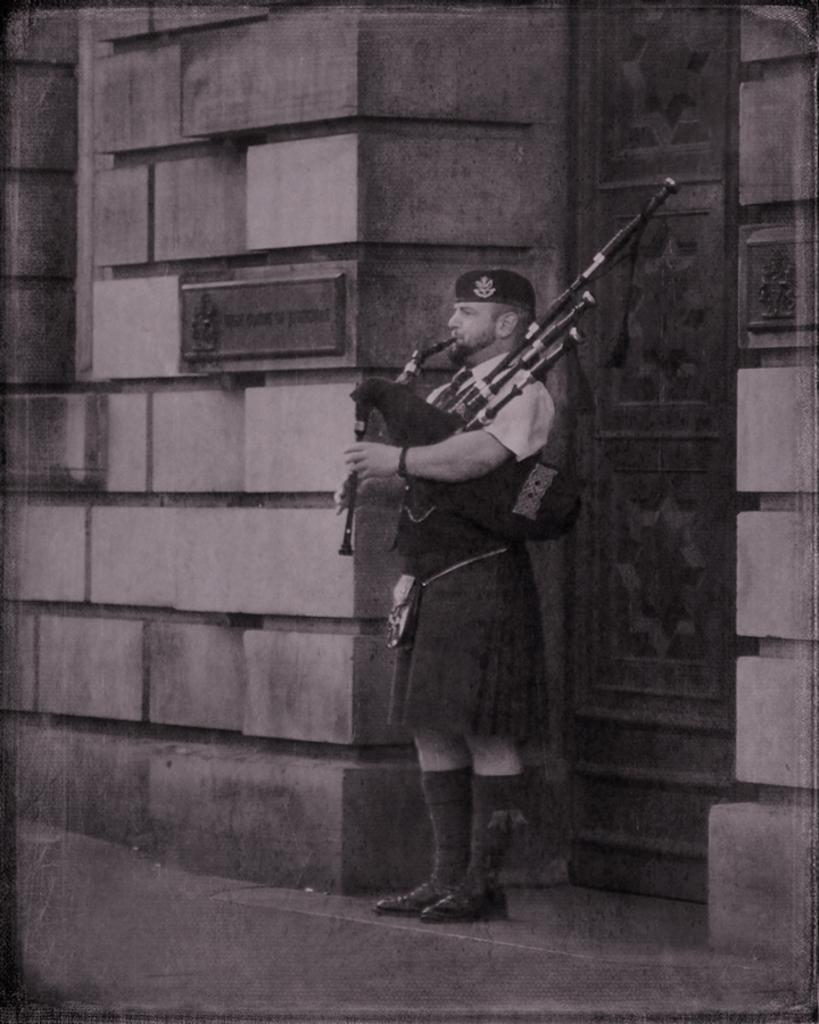What is the color scheme of the image? The image is black and white. Who is present in the image? There is a man in the image. What is the man holding in the image? The man is holding a musical instrument. What can be seen in the background of the image? There is a wall, a door, and a board in the background of the image. How many giants are visible in the image? There are no giants present in the image. What type of wood is used to make the musical instrument in the image? The image is black and white, so it is not possible to determine the type of wood used to make the musical instrument. 